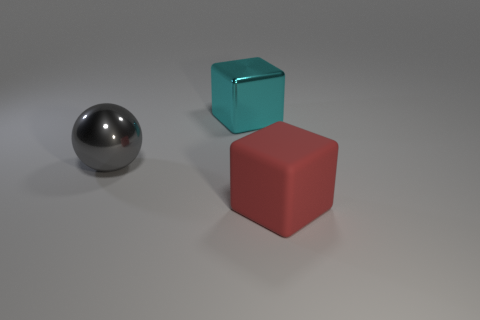Add 2 large brown matte cylinders. How many objects exist? 5 Subtract all blocks. How many objects are left? 1 Subtract 0 red cylinders. How many objects are left? 3 Subtract all large brown matte cylinders. Subtract all gray metallic objects. How many objects are left? 2 Add 2 large shiny objects. How many large shiny objects are left? 4 Add 3 spheres. How many spheres exist? 4 